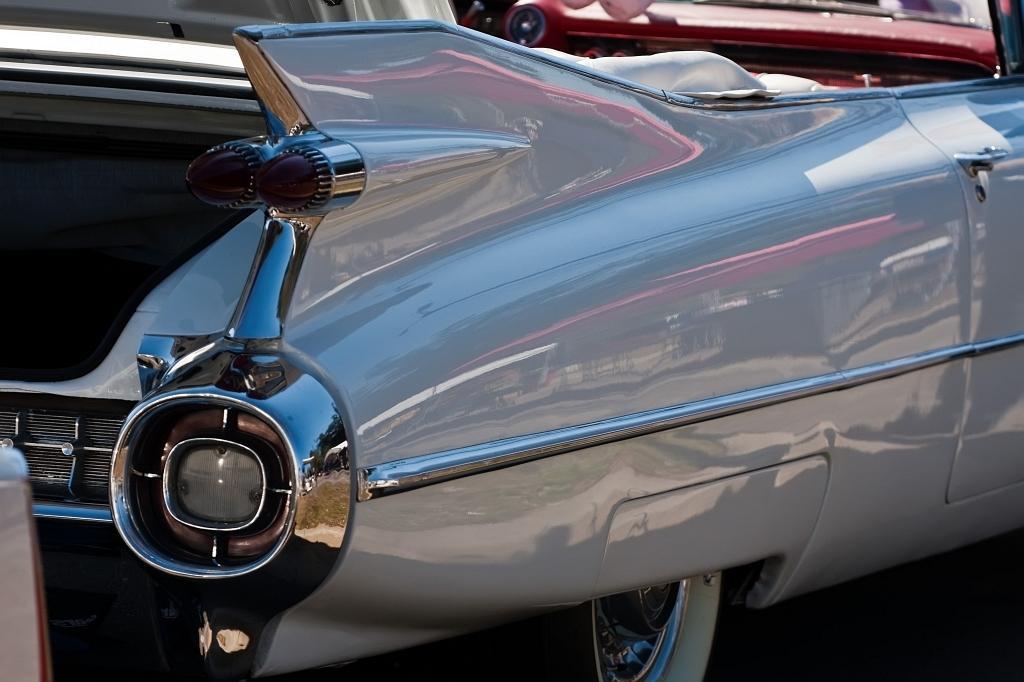In one or two sentences, can you explain what this image depicts? In this picture we can see a few vehicles. We can see the reflections of a few objects on the grey object. 